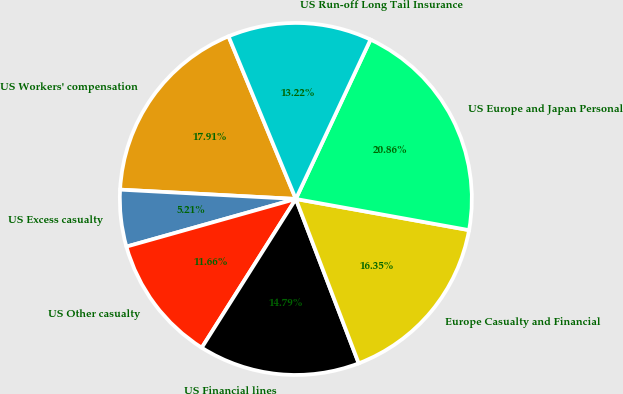<chart> <loc_0><loc_0><loc_500><loc_500><pie_chart><fcel>US Workers' compensation<fcel>US Excess casualty<fcel>US Other casualty<fcel>US Financial lines<fcel>Europe Casualty and Financial<fcel>US Europe and Japan Personal<fcel>US Run-off Long Tail Insurance<nl><fcel>17.91%<fcel>5.21%<fcel>11.66%<fcel>14.79%<fcel>16.35%<fcel>20.86%<fcel>13.22%<nl></chart> 